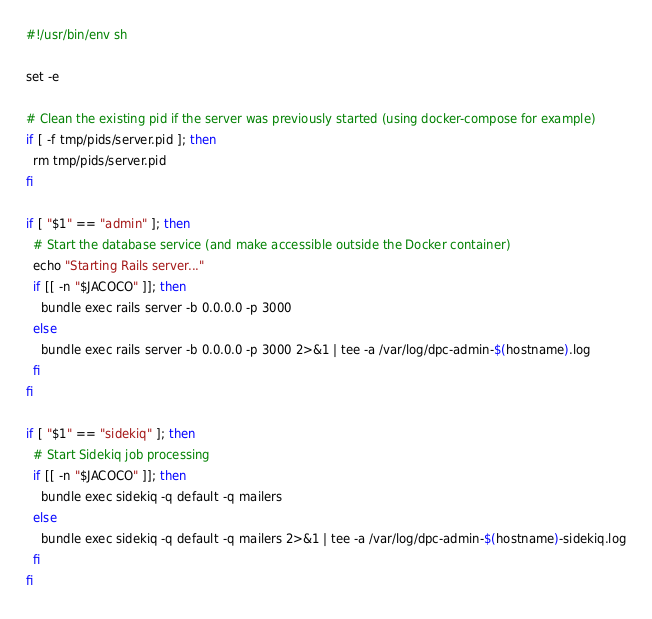<code> <loc_0><loc_0><loc_500><loc_500><_Bash_>#!/usr/bin/env sh

set -e

# Clean the existing pid if the server was previously started (using docker-compose for example)
if [ -f tmp/pids/server.pid ]; then
  rm tmp/pids/server.pid
fi

if [ "$1" == "admin" ]; then
  # Start the database service (and make accessible outside the Docker container)
  echo "Starting Rails server..."
  if [[ -n "$JACOCO" ]]; then
    bundle exec rails server -b 0.0.0.0 -p 3000
  else
    bundle exec rails server -b 0.0.0.0 -p 3000 2>&1 | tee -a /var/log/dpc-admin-$(hostname).log
  fi
fi

if [ "$1" == "sidekiq" ]; then
  # Start Sidekiq job processing
  if [[ -n "$JACOCO" ]]; then
    bundle exec sidekiq -q default -q mailers
  else
    bundle exec sidekiq -q default -q mailers 2>&1 | tee -a /var/log/dpc-admin-$(hostname)-sidekiq.log
  fi
fi
</code> 